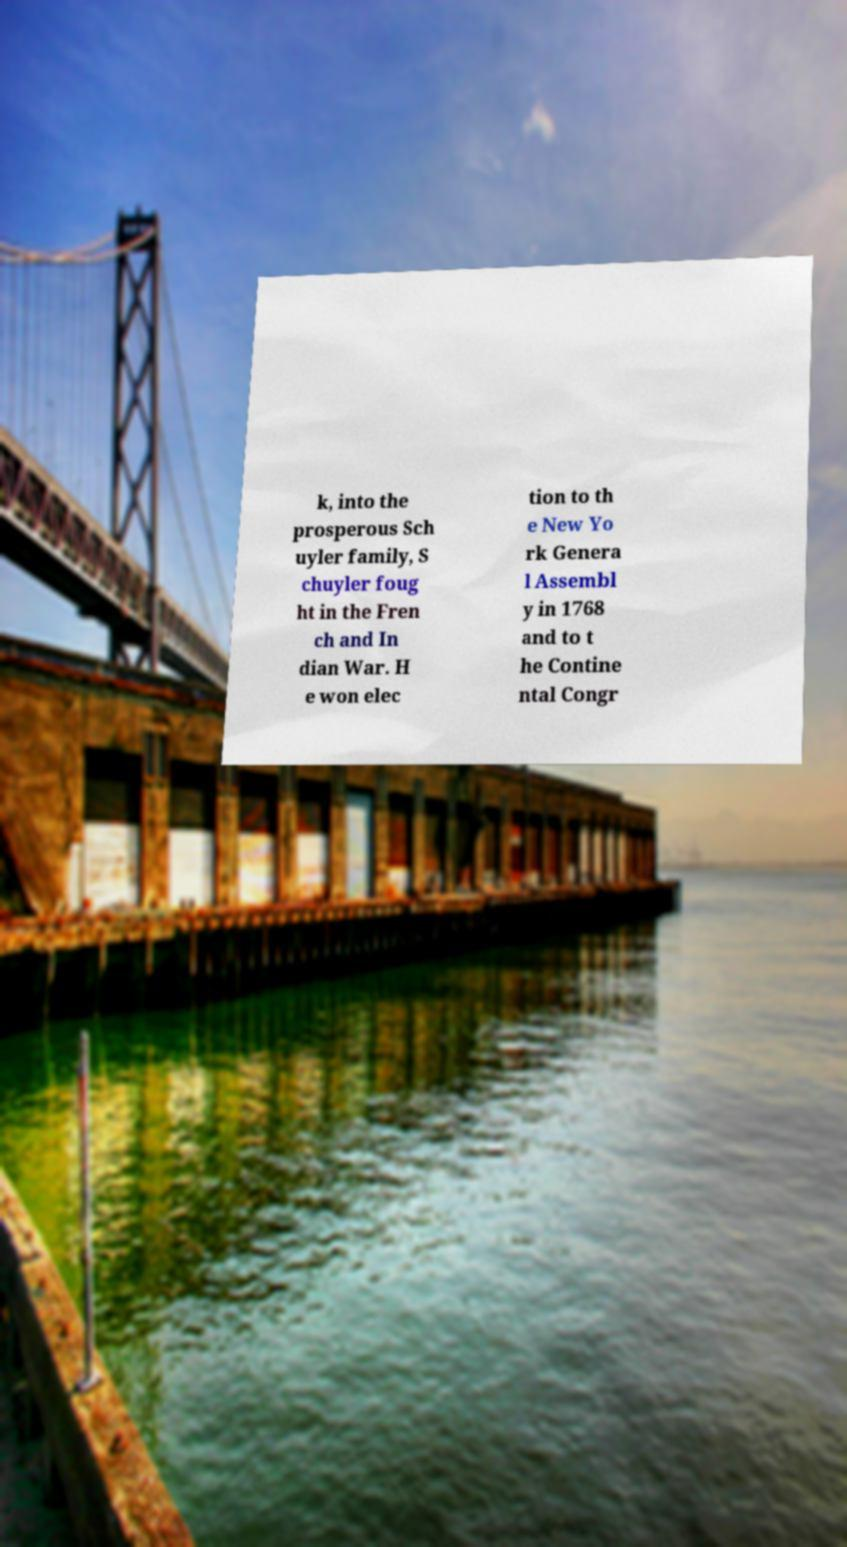What messages or text are displayed in this image? I need them in a readable, typed format. k, into the prosperous Sch uyler family, S chuyler foug ht in the Fren ch and In dian War. H e won elec tion to th e New Yo rk Genera l Assembl y in 1768 and to t he Contine ntal Congr 